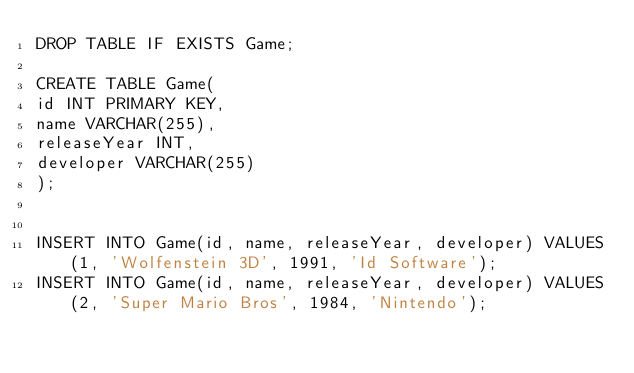Convert code to text. <code><loc_0><loc_0><loc_500><loc_500><_SQL_>DROP TABLE IF EXISTS Game;

CREATE TABLE Game(
id INT PRIMARY KEY,
name VARCHAR(255),
releaseYear INT,
developer VARCHAR(255)
);


INSERT INTO Game(id, name, releaseYear, developer) VALUES(1, 'Wolfenstein 3D', 1991, 'Id Software');
INSERT INTO Game(id, name, releaseYear, developer) VALUES(2, 'Super Mario Bros', 1984, 'Nintendo');</code> 